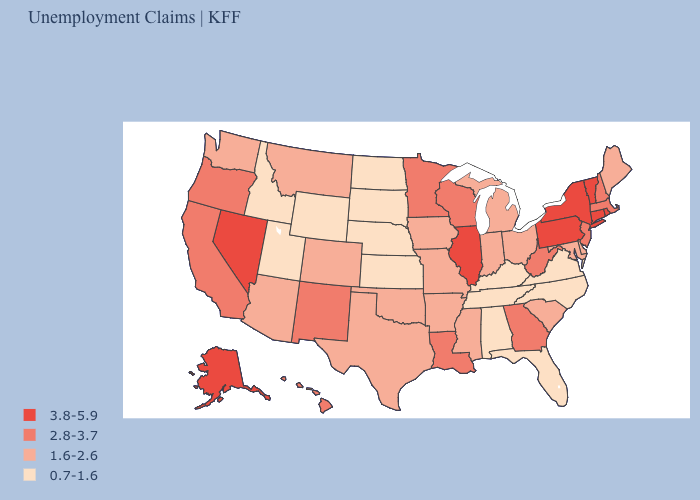Does Nevada have a higher value than Wisconsin?
Concise answer only. Yes. Among the states that border New York , does Connecticut have the highest value?
Concise answer only. Yes. Name the states that have a value in the range 0.7-1.6?
Quick response, please. Alabama, Florida, Idaho, Kansas, Kentucky, Nebraska, North Carolina, North Dakota, South Dakota, Tennessee, Utah, Virginia, Wyoming. What is the value of Georgia?
Give a very brief answer. 2.8-3.7. Which states have the highest value in the USA?
Concise answer only. Alaska, Connecticut, Illinois, Nevada, New York, Pennsylvania, Rhode Island, Vermont. What is the value of North Dakota?
Be succinct. 0.7-1.6. Which states have the lowest value in the Northeast?
Short answer required. Maine. Which states hav the highest value in the MidWest?
Short answer required. Illinois. Does the map have missing data?
Concise answer only. No. Among the states that border Rhode Island , which have the highest value?
Answer briefly. Connecticut. Name the states that have a value in the range 1.6-2.6?
Be succinct. Arizona, Arkansas, Colorado, Delaware, Indiana, Iowa, Maine, Maryland, Michigan, Mississippi, Missouri, Montana, Ohio, Oklahoma, South Carolina, Texas, Washington. Which states have the lowest value in the USA?
Keep it brief. Alabama, Florida, Idaho, Kansas, Kentucky, Nebraska, North Carolina, North Dakota, South Dakota, Tennessee, Utah, Virginia, Wyoming. Name the states that have a value in the range 1.6-2.6?
Keep it brief. Arizona, Arkansas, Colorado, Delaware, Indiana, Iowa, Maine, Maryland, Michigan, Mississippi, Missouri, Montana, Ohio, Oklahoma, South Carolina, Texas, Washington. Name the states that have a value in the range 0.7-1.6?
Be succinct. Alabama, Florida, Idaho, Kansas, Kentucky, Nebraska, North Carolina, North Dakota, South Dakota, Tennessee, Utah, Virginia, Wyoming. 